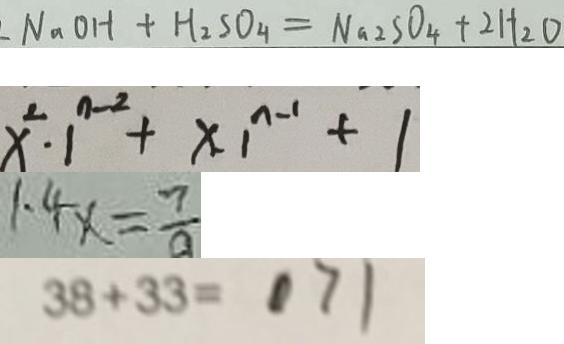Convert formula to latex. <formula><loc_0><loc_0><loc_500><loc_500>N _ { 2 } O H + H _ { 2 } S O _ { 4 } = N a _ { 2 } S O _ { 4 } + 2 H _ { 2 } O 
 x ^ { 2 } \cdot 1 ^ { n - 2 } + x \cdot 1 ^ { n - 1 } + 1 
 1 . 4 x = \frac { 7 } { a } 
 3 8 + 3 3 = 7 1</formula> 